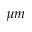<formula> <loc_0><loc_0><loc_500><loc_500>\mu m</formula> 